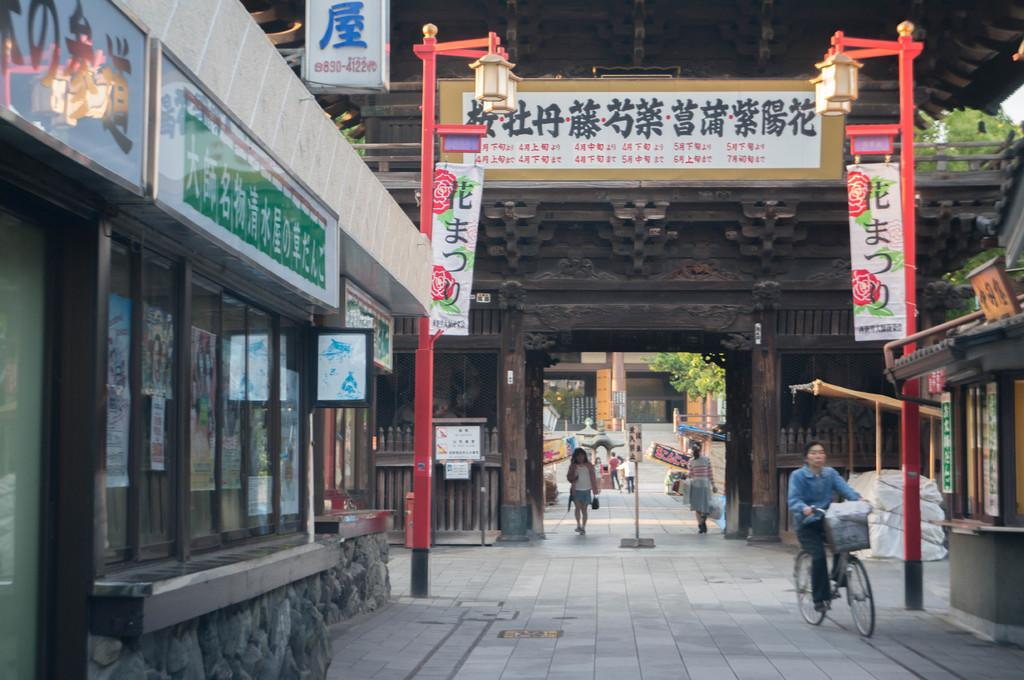What is the person in the image doing? The person is sitting and riding a bicycle. What objects can be seen in the image besides the person and the bicycle? There are boards, glass, lights on poles, and a board on a pole in the background visible in the image. What can be seen in the background of the image? In the background, there are people, a building, a tree, and a board on a pole. What type of sponge is being used for amusement in the image? There is no sponge present in the image, and no amusement activity involving a sponge can be observed. 